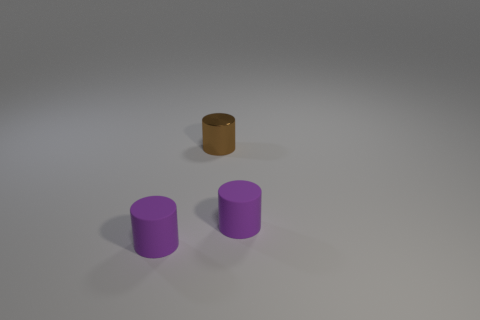Is there a big red object of the same shape as the brown metal thing?
Offer a very short reply. No. What shape is the rubber thing to the left of the purple cylinder that is to the right of the tiny brown metal cylinder?
Ensure brevity in your answer.  Cylinder. There is a small brown metallic object; what shape is it?
Offer a terse response. Cylinder. What material is the cylinder in front of the matte object that is behind the purple rubber object that is on the left side of the metallic cylinder?
Offer a very short reply. Rubber. What number of other things are the same material as the tiny brown cylinder?
Give a very brief answer. 0. There is a tiny purple matte cylinder that is right of the brown metal cylinder; what number of purple cylinders are in front of it?
Offer a terse response. 1. How many cylinders are matte objects or brown metallic things?
Offer a very short reply. 3. Is there anything else that has the same color as the tiny metallic cylinder?
Your answer should be compact. No. There is a matte cylinder right of the tiny matte cylinder on the left side of the small metal thing; what is its color?
Offer a terse response. Purple. Is the tiny object that is left of the brown metallic cylinder made of the same material as the object that is to the right of the brown object?
Your answer should be very brief. Yes. 